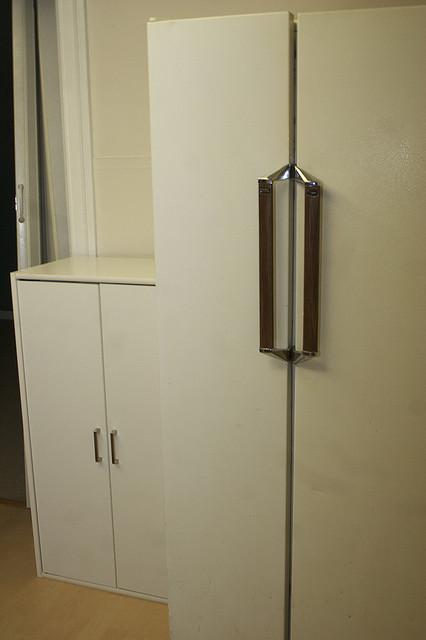How many handles are shown?
Give a very brief answer. 4. 